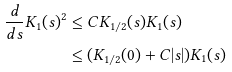Convert formula to latex. <formula><loc_0><loc_0><loc_500><loc_500>\frac { d } { d s } K _ { 1 } ( s ) ^ { 2 } & \leq C K _ { 1 / 2 } ( s ) K _ { 1 } ( s ) \\ & \leq ( K _ { 1 / 2 } ( 0 ) + C | s | ) K _ { 1 } ( s )</formula> 